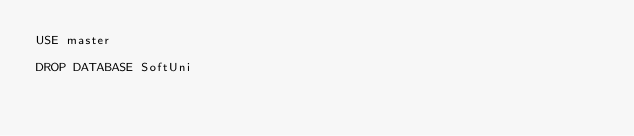Convert code to text. <code><loc_0><loc_0><loc_500><loc_500><_SQL_>USE master

DROP DATABASE SoftUni</code> 